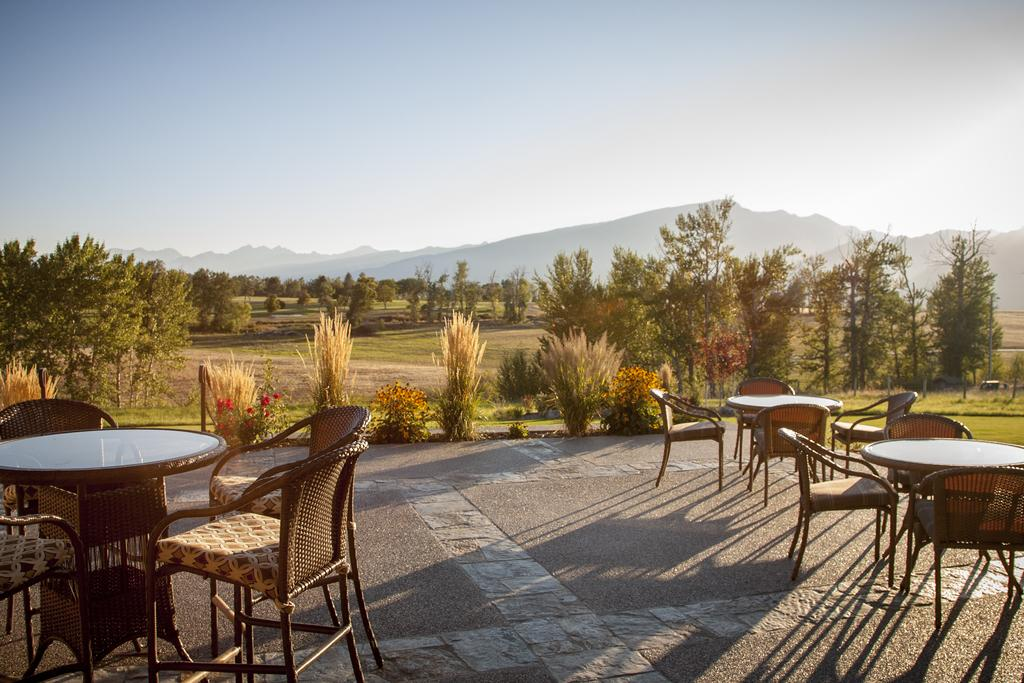What type of furniture is on the floor in the image? There are tables and chairs on the floor in the image. What type of vegetation can be seen in the image? There are plants, trees, and grass in the image. What type of natural landform is visible in the image? There are mountains in the image. What part of the natural environment is visible in the background of the image? The sky is visible in the background of the image. What type of reward is being given to the son in the image? There is no son or reward present in the image. What type of cemetery can be seen in the image? There is no cemetery present in the image. 